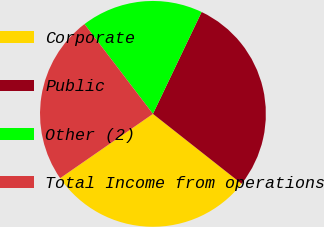Convert chart to OTSL. <chart><loc_0><loc_0><loc_500><loc_500><pie_chart><fcel>Corporate<fcel>Public<fcel>Other (2)<fcel>Total Income from operations<nl><fcel>29.73%<fcel>28.53%<fcel>17.46%<fcel>24.28%<nl></chart> 